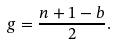Convert formula to latex. <formula><loc_0><loc_0><loc_500><loc_500>g = \frac { n + 1 - b } { 2 } .</formula> 